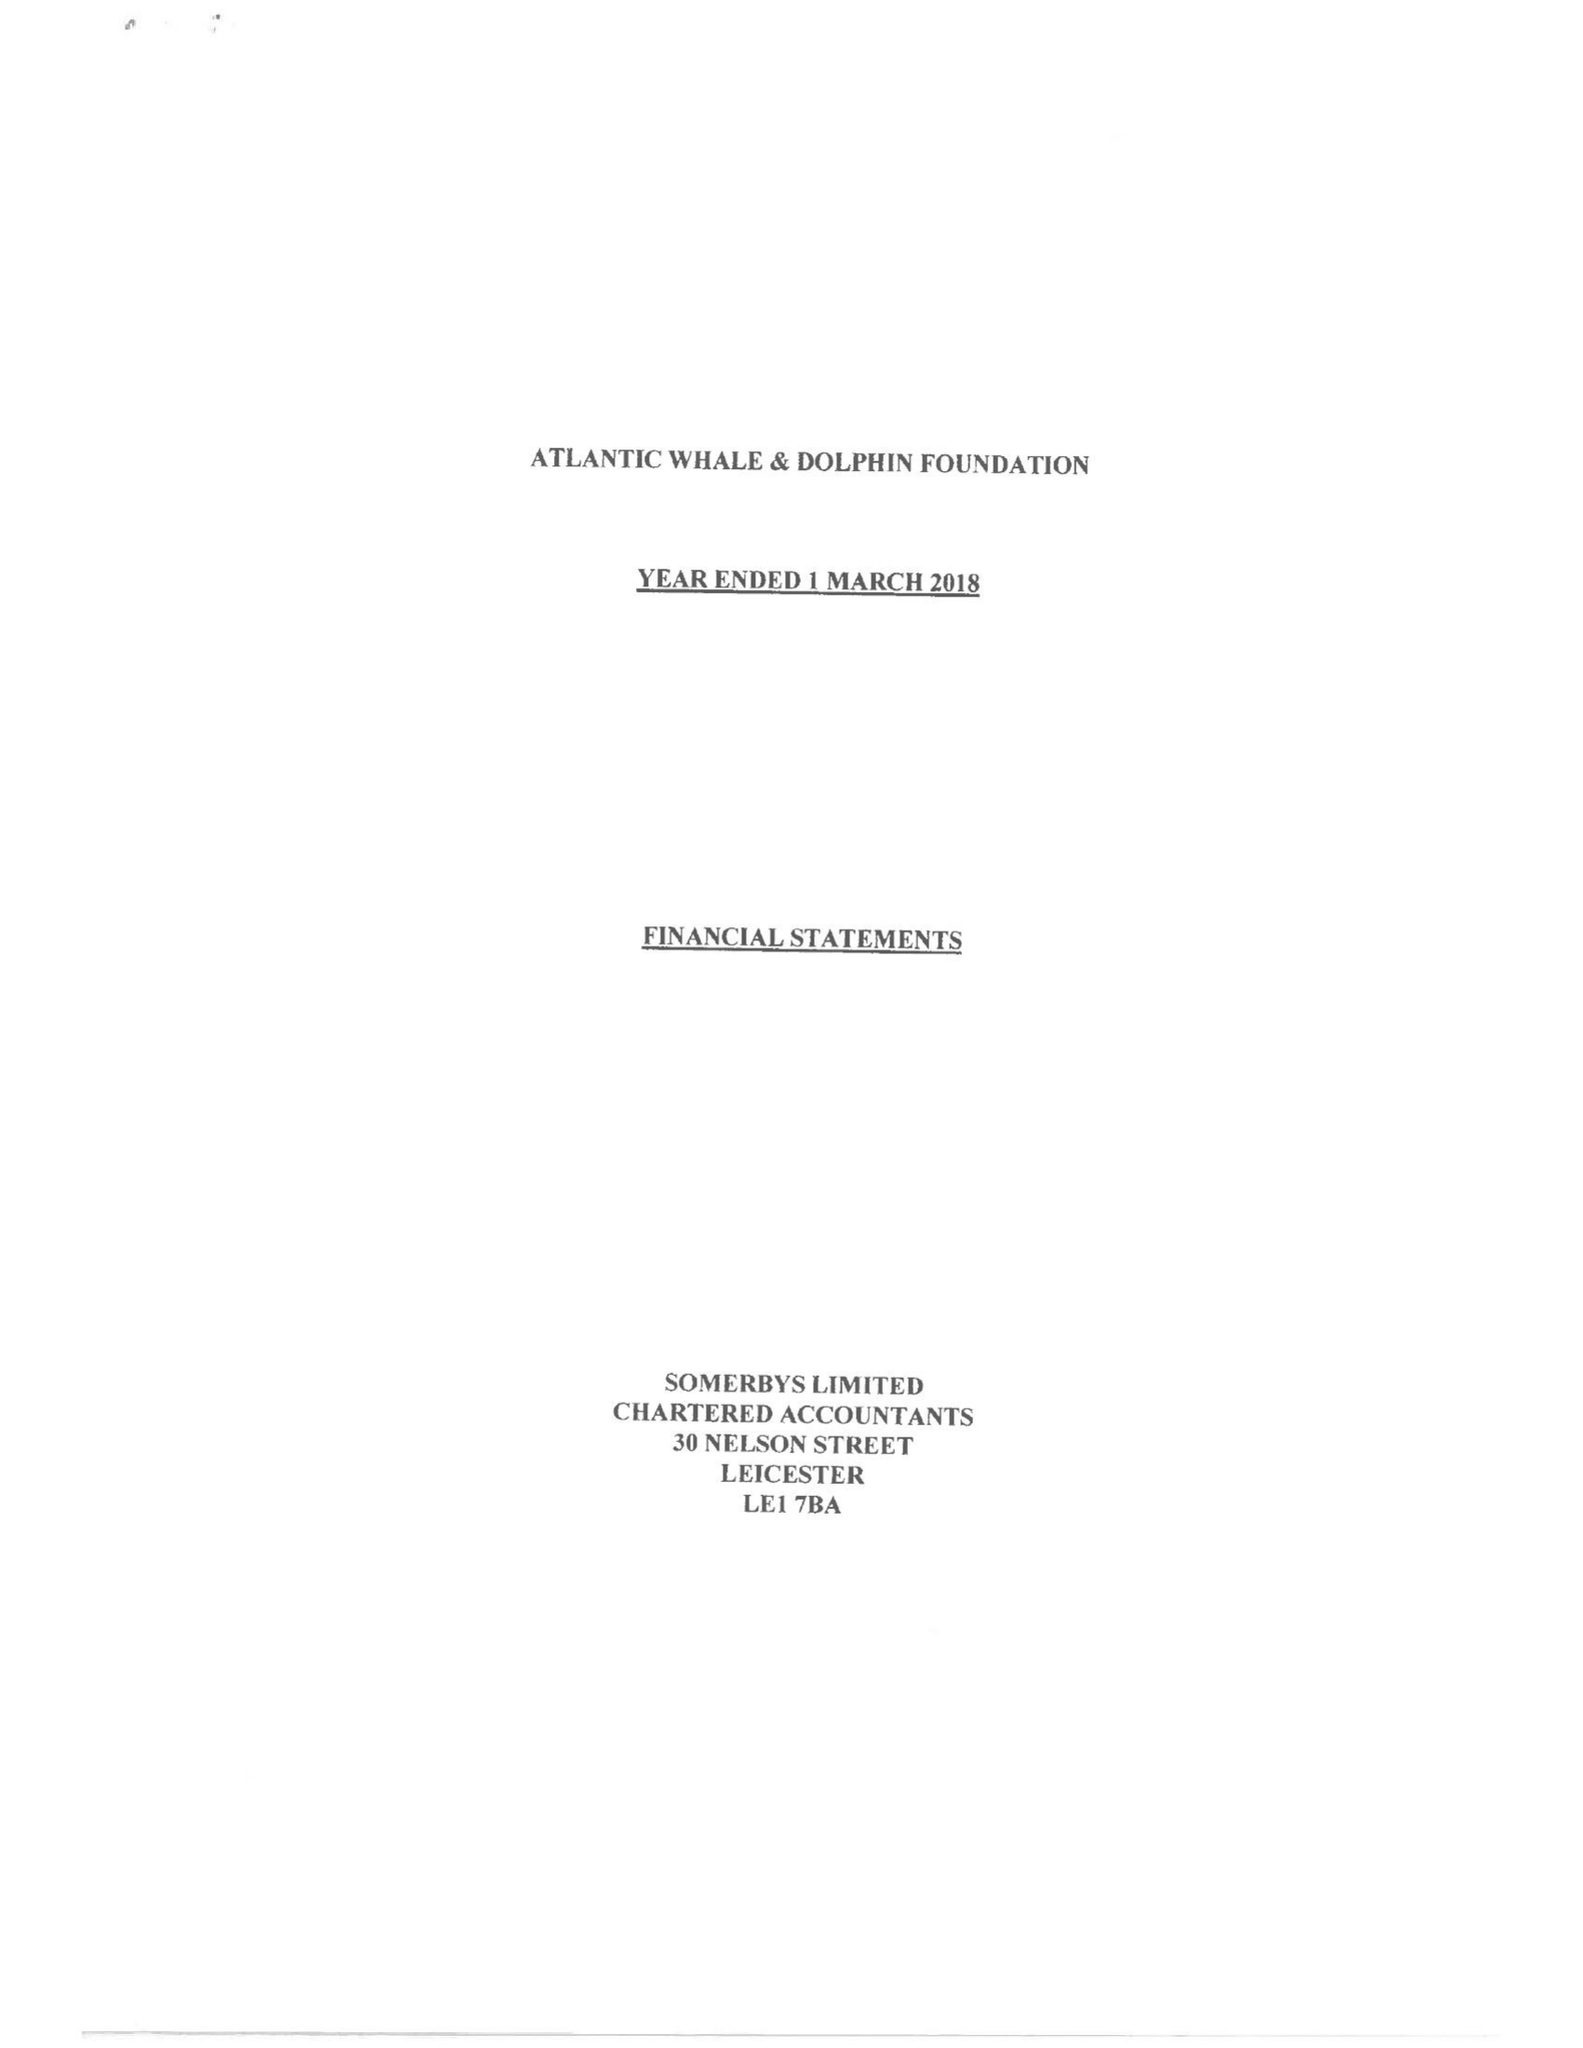What is the value for the address__postcode?
Answer the question using a single word or phrase. LE16 7AQ 